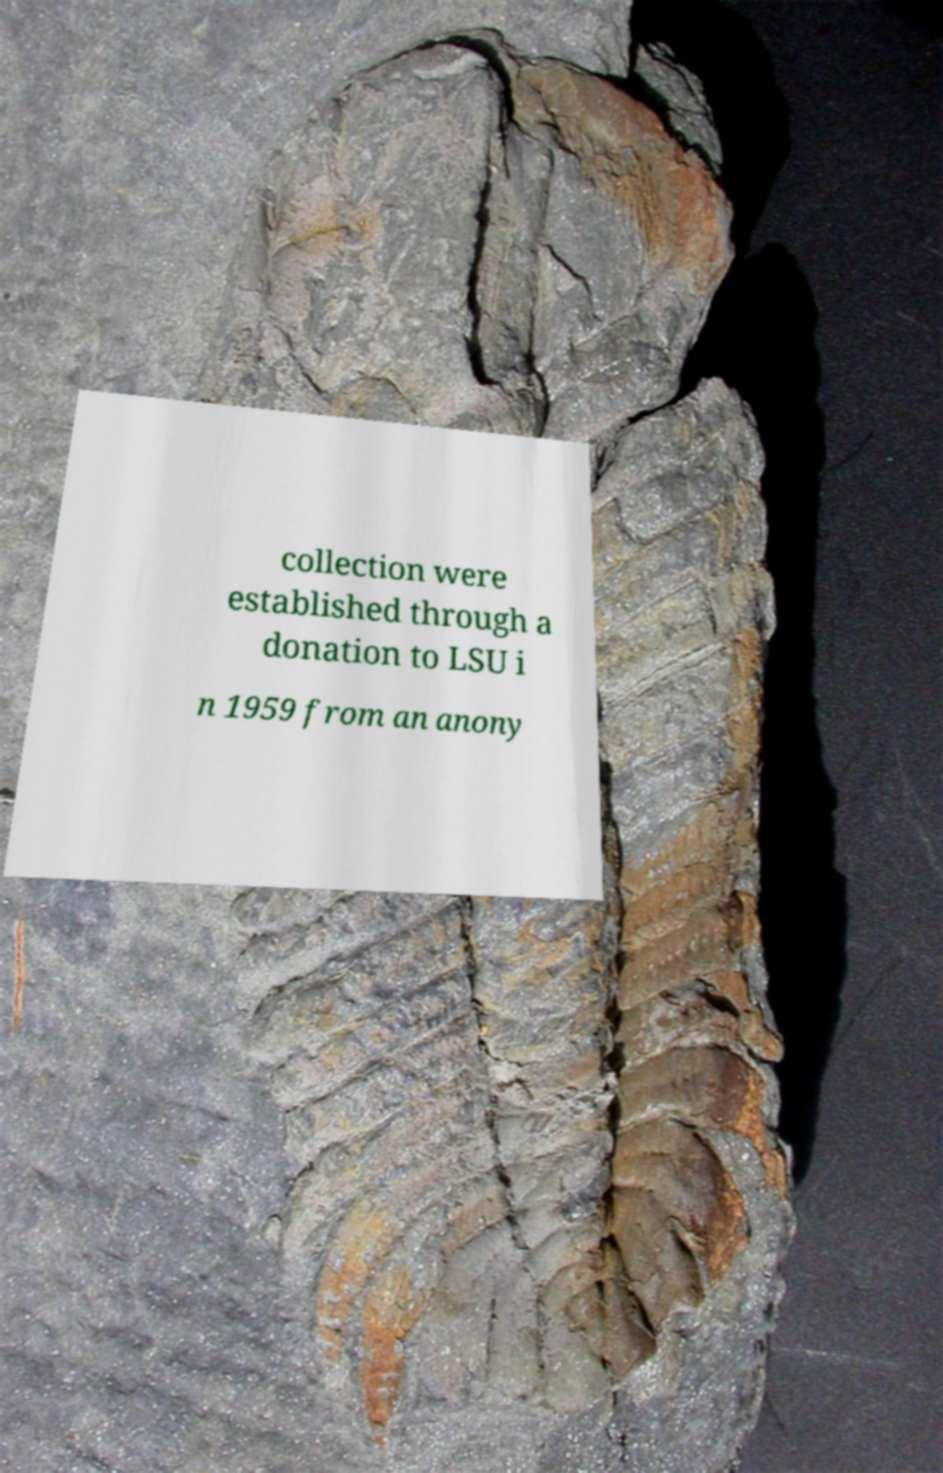Can you accurately transcribe the text from the provided image for me? collection were established through a donation to LSU i n 1959 from an anony 